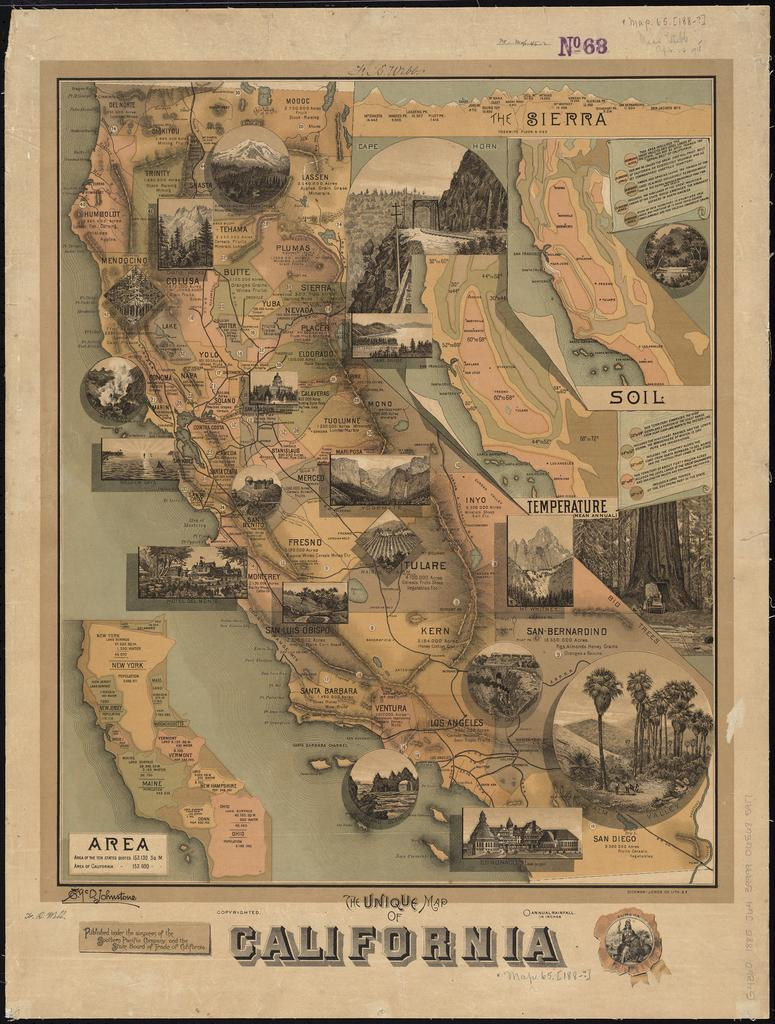<image>
Offer a succinct explanation of the picture presented. Old antique illustrated showing the unique map of California 